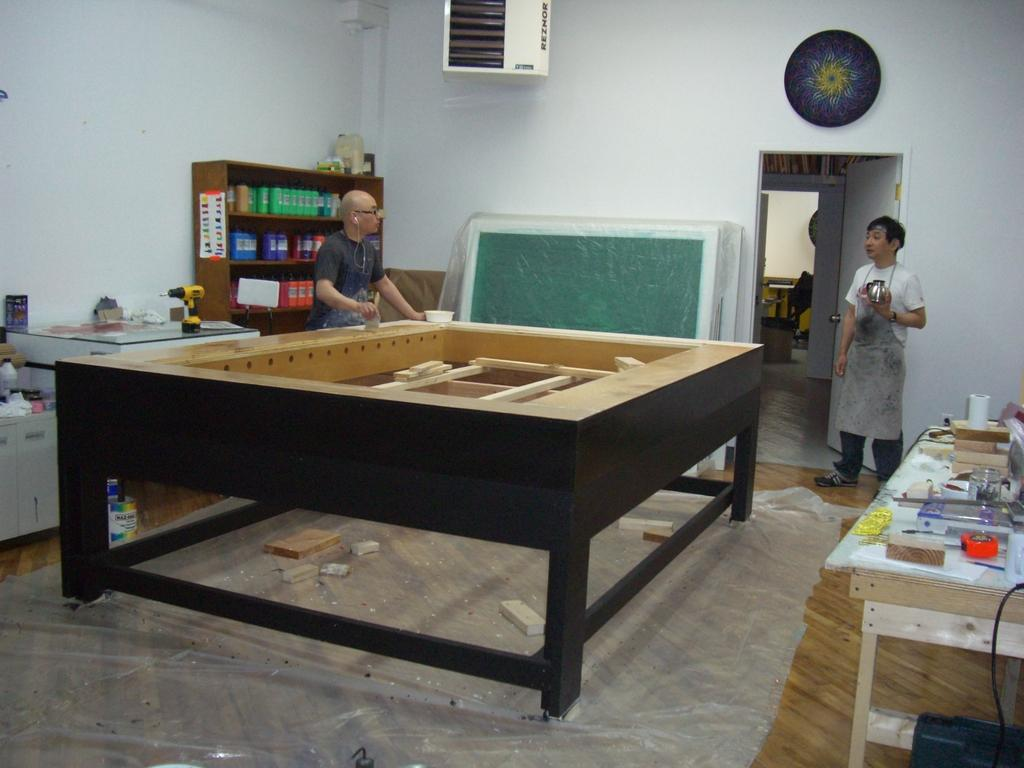How many people are in the image? There are two persons in the image. What are the two persons doing? Both persons are looking at each other. What is one of the persons doing specifically? One of the persons is doing painting work. What can be seen behind the person doing the painting work? There is painting stuff behind the person doing the painting work. What type of boundary can be seen between the two persons in the image? There is no boundary visible between the two persons in the image; they are simply looking at each other. What kind of roll is being used by the person doing the painting work? There is no roll visible in the image; the person doing the painting work is likely using a brush or other painting tool. 